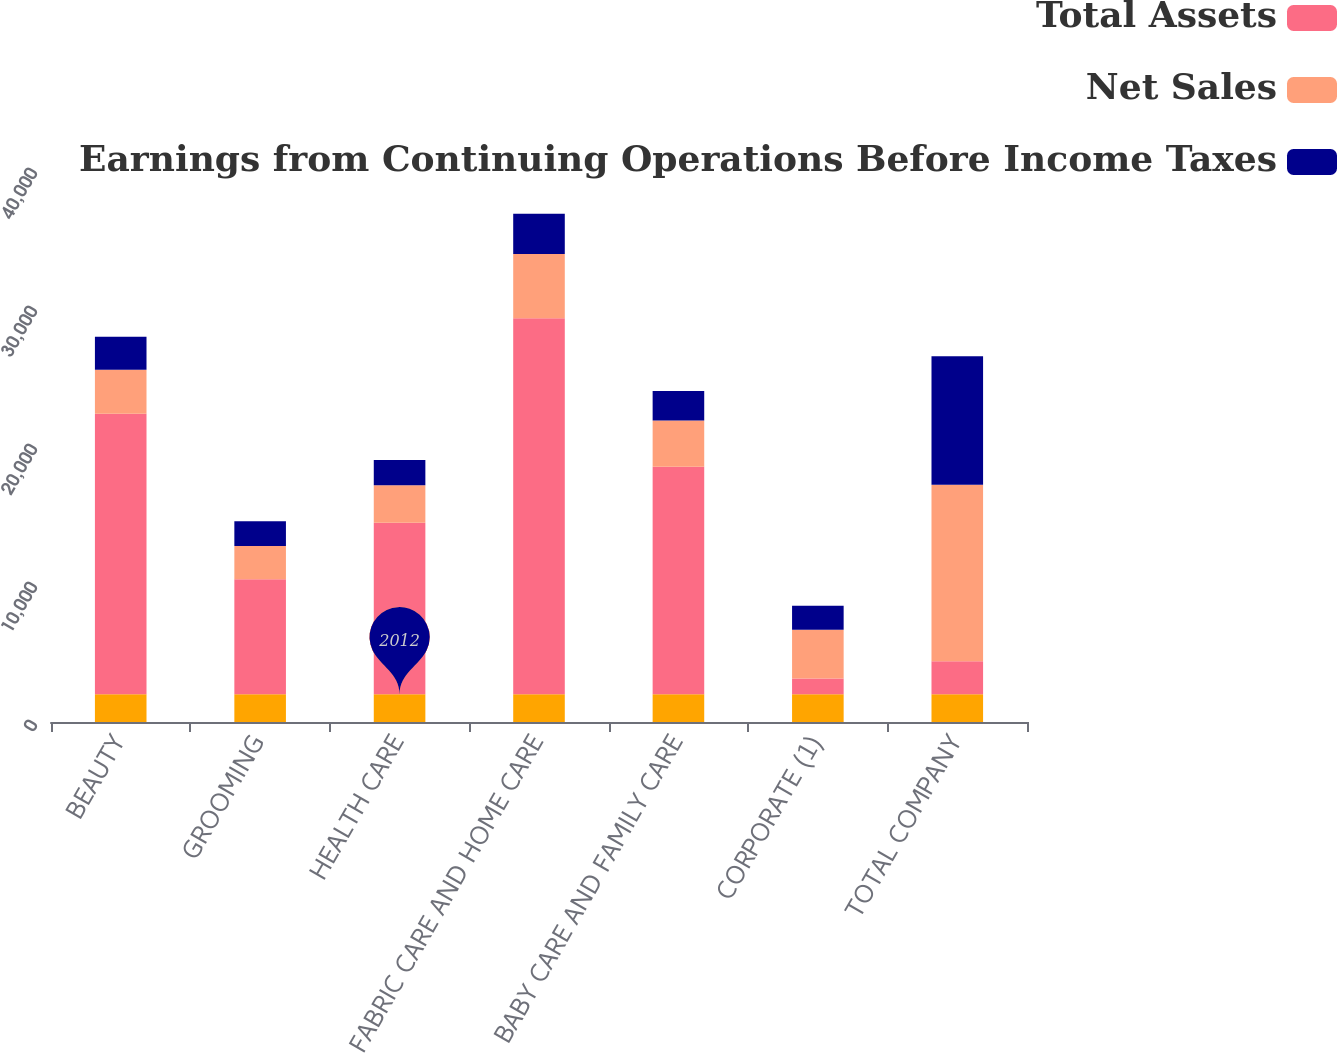Convert chart. <chart><loc_0><loc_0><loc_500><loc_500><stacked_bar_chart><ecel><fcel>BEAUTY<fcel>GROOMING<fcel>HEALTH CARE<fcel>FABRIC CARE AND HOME CARE<fcel>BABY CARE AND FAMILY CARE<fcel>CORPORATE (1)<fcel>TOTAL COMPANY<nl><fcel>nan<fcel>2012<fcel>2012<fcel>2012<fcel>2012<fcel>2012<fcel>2012<fcel>2012<nl><fcel>Total Assets<fcel>20318<fcel>8339<fcel>12421<fcel>27254<fcel>16493<fcel>1145<fcel>2395<nl><fcel>Net Sales<fcel>3196<fcel>2395<fcel>2718<fcel>4645<fcel>3351<fcel>3520<fcel>12785<nl><fcel>Earnings from Continuing Operations Before Income Taxes<fcel>2390<fcel>1807<fcel>1826<fcel>2915<fcel>2123<fcel>1744<fcel>9317<nl></chart> 